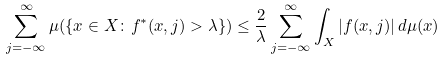Convert formula to latex. <formula><loc_0><loc_0><loc_500><loc_500>\sum _ { j = - \infty } ^ { \infty } \mu ( \{ x \in X \colon f ^ { * } ( x , j ) > \lambda \} ) \leq \frac { 2 } { \lambda } \sum _ { j = - \infty } ^ { \infty } \int _ { X } | f ( x , j ) | \, d \mu ( x )</formula> 